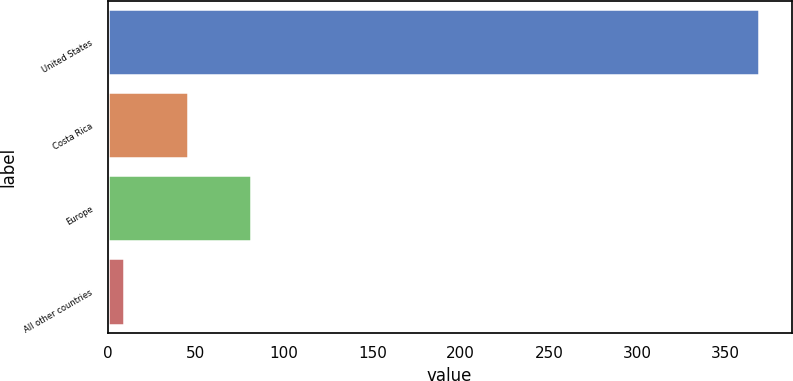<chart> <loc_0><loc_0><loc_500><loc_500><bar_chart><fcel>United States<fcel>Costa Rica<fcel>Europe<fcel>All other countries<nl><fcel>369.1<fcel>45.46<fcel>81.42<fcel>9.5<nl></chart> 